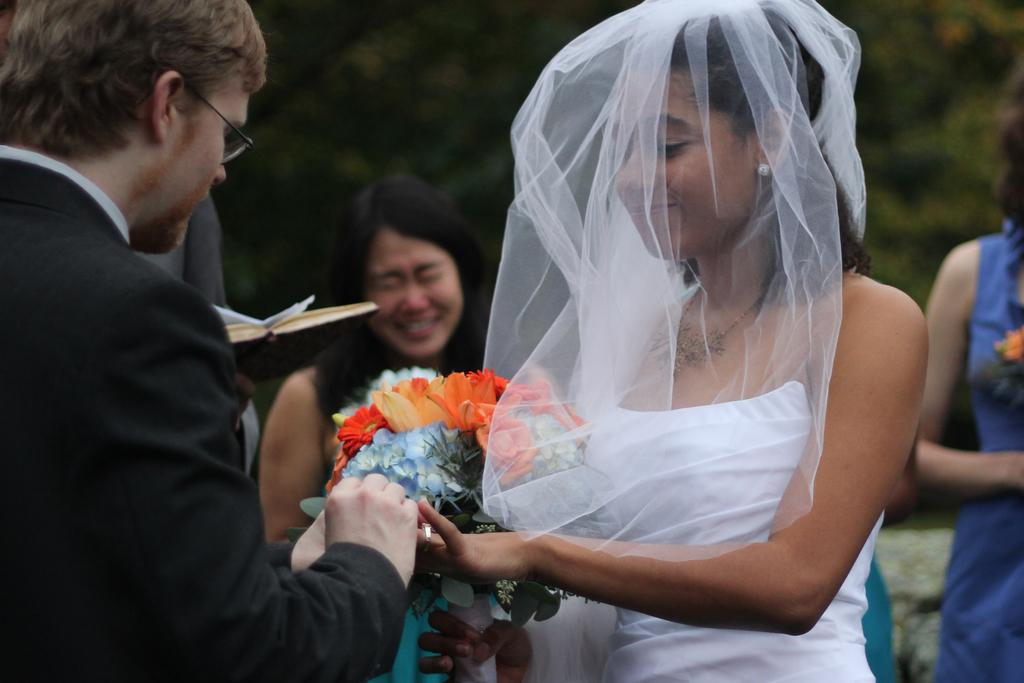What types of people are in the image? There are men and women in the image. What are the men and women doing in the image? The men and women are standing. What can be seen in the background of the image? There are trees in the background of the image. What type of record can be seen on the ground in the image? There is no record present in the image; it features men and women standing with trees in the background. 